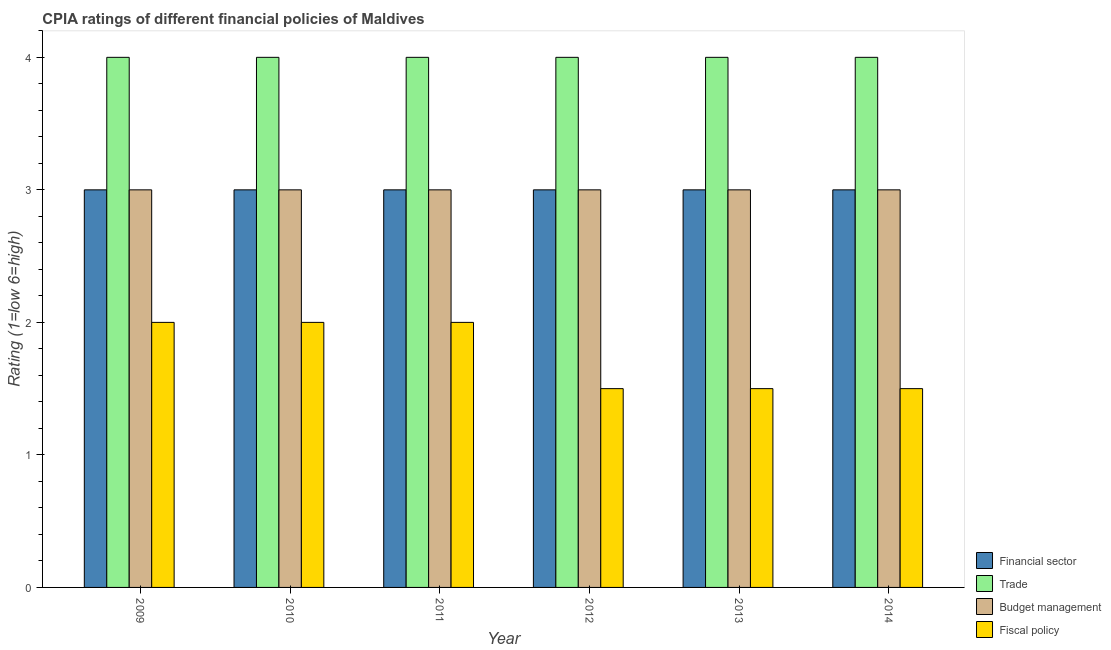How many groups of bars are there?
Make the answer very short. 6. Are the number of bars per tick equal to the number of legend labels?
Ensure brevity in your answer.  Yes. How many bars are there on the 2nd tick from the left?
Your answer should be compact. 4. What is the cpia rating of budget management in 2011?
Provide a short and direct response. 3. Across all years, what is the maximum cpia rating of trade?
Provide a short and direct response. 4. Across all years, what is the minimum cpia rating of budget management?
Ensure brevity in your answer.  3. In which year was the cpia rating of budget management maximum?
Offer a very short reply. 2009. In which year was the cpia rating of financial sector minimum?
Your answer should be very brief. 2009. What is the total cpia rating of trade in the graph?
Keep it short and to the point. 24. In how many years, is the cpia rating of trade greater than 1.8?
Your response must be concise. 6. Is the cpia rating of fiscal policy in 2013 less than that in 2014?
Ensure brevity in your answer.  No. Is the difference between the cpia rating of financial sector in 2011 and 2013 greater than the difference between the cpia rating of budget management in 2011 and 2013?
Your answer should be very brief. No. What is the difference between the highest and the second highest cpia rating of fiscal policy?
Your response must be concise. 0. Is the sum of the cpia rating of fiscal policy in 2012 and 2013 greater than the maximum cpia rating of financial sector across all years?
Your answer should be compact. Yes. What does the 4th bar from the left in 2011 represents?
Your answer should be very brief. Fiscal policy. What does the 4th bar from the right in 2010 represents?
Offer a very short reply. Financial sector. How many bars are there?
Make the answer very short. 24. Are all the bars in the graph horizontal?
Provide a succinct answer. No. How many years are there in the graph?
Make the answer very short. 6. What is the difference between two consecutive major ticks on the Y-axis?
Keep it short and to the point. 1. Does the graph contain any zero values?
Offer a very short reply. No. Does the graph contain grids?
Give a very brief answer. No. Where does the legend appear in the graph?
Your response must be concise. Bottom right. What is the title of the graph?
Ensure brevity in your answer.  CPIA ratings of different financial policies of Maldives. What is the label or title of the X-axis?
Keep it short and to the point. Year. What is the Rating (1=low 6=high) of Financial sector in 2009?
Your answer should be compact. 3. What is the Rating (1=low 6=high) in Budget management in 2009?
Offer a terse response. 3. What is the Rating (1=low 6=high) in Fiscal policy in 2010?
Keep it short and to the point. 2. What is the Rating (1=low 6=high) in Financial sector in 2011?
Provide a short and direct response. 3. What is the Rating (1=low 6=high) in Trade in 2011?
Your response must be concise. 4. What is the Rating (1=low 6=high) of Budget management in 2011?
Offer a very short reply. 3. What is the Rating (1=low 6=high) in Fiscal policy in 2012?
Offer a terse response. 1.5. What is the Rating (1=low 6=high) in Fiscal policy in 2013?
Your answer should be compact. 1.5. What is the Rating (1=low 6=high) in Budget management in 2014?
Ensure brevity in your answer.  3. Across all years, what is the maximum Rating (1=low 6=high) of Trade?
Offer a terse response. 4. Across all years, what is the maximum Rating (1=low 6=high) of Budget management?
Offer a very short reply. 3. Across all years, what is the maximum Rating (1=low 6=high) of Fiscal policy?
Your answer should be very brief. 2. Across all years, what is the minimum Rating (1=low 6=high) in Financial sector?
Your response must be concise. 3. Across all years, what is the minimum Rating (1=low 6=high) of Trade?
Provide a short and direct response. 4. What is the total Rating (1=low 6=high) in Trade in the graph?
Make the answer very short. 24. What is the total Rating (1=low 6=high) in Budget management in the graph?
Keep it short and to the point. 18. What is the total Rating (1=low 6=high) in Fiscal policy in the graph?
Keep it short and to the point. 10.5. What is the difference between the Rating (1=low 6=high) of Financial sector in 2009 and that in 2010?
Your answer should be compact. 0. What is the difference between the Rating (1=low 6=high) of Budget management in 2009 and that in 2011?
Offer a very short reply. 0. What is the difference between the Rating (1=low 6=high) in Fiscal policy in 2009 and that in 2011?
Ensure brevity in your answer.  0. What is the difference between the Rating (1=low 6=high) of Financial sector in 2009 and that in 2012?
Ensure brevity in your answer.  0. What is the difference between the Rating (1=low 6=high) in Financial sector in 2009 and that in 2013?
Offer a terse response. 0. What is the difference between the Rating (1=low 6=high) of Budget management in 2009 and that in 2013?
Provide a succinct answer. 0. What is the difference between the Rating (1=low 6=high) of Financial sector in 2009 and that in 2014?
Ensure brevity in your answer.  0. What is the difference between the Rating (1=low 6=high) in Fiscal policy in 2009 and that in 2014?
Ensure brevity in your answer.  0.5. What is the difference between the Rating (1=low 6=high) of Budget management in 2010 and that in 2011?
Offer a terse response. 0. What is the difference between the Rating (1=low 6=high) in Financial sector in 2010 and that in 2012?
Make the answer very short. 0. What is the difference between the Rating (1=low 6=high) of Trade in 2010 and that in 2012?
Give a very brief answer. 0. What is the difference between the Rating (1=low 6=high) of Fiscal policy in 2010 and that in 2012?
Provide a short and direct response. 0.5. What is the difference between the Rating (1=low 6=high) of Budget management in 2010 and that in 2013?
Your answer should be compact. 0. What is the difference between the Rating (1=low 6=high) of Fiscal policy in 2010 and that in 2013?
Ensure brevity in your answer.  0.5. What is the difference between the Rating (1=low 6=high) of Financial sector in 2010 and that in 2014?
Offer a terse response. 0. What is the difference between the Rating (1=low 6=high) of Trade in 2010 and that in 2014?
Keep it short and to the point. 0. What is the difference between the Rating (1=low 6=high) in Budget management in 2011 and that in 2012?
Offer a terse response. 0. What is the difference between the Rating (1=low 6=high) of Fiscal policy in 2011 and that in 2012?
Offer a very short reply. 0.5. What is the difference between the Rating (1=low 6=high) of Financial sector in 2011 and that in 2013?
Keep it short and to the point. 0. What is the difference between the Rating (1=low 6=high) of Fiscal policy in 2011 and that in 2013?
Provide a succinct answer. 0.5. What is the difference between the Rating (1=low 6=high) of Budget management in 2011 and that in 2014?
Your answer should be compact. 0. What is the difference between the Rating (1=low 6=high) of Fiscal policy in 2011 and that in 2014?
Provide a succinct answer. 0.5. What is the difference between the Rating (1=low 6=high) of Financial sector in 2012 and that in 2013?
Ensure brevity in your answer.  0. What is the difference between the Rating (1=low 6=high) in Financial sector in 2012 and that in 2014?
Offer a very short reply. 0. What is the difference between the Rating (1=low 6=high) in Trade in 2012 and that in 2014?
Give a very brief answer. 0. What is the difference between the Rating (1=low 6=high) in Budget management in 2012 and that in 2014?
Provide a short and direct response. 0. What is the difference between the Rating (1=low 6=high) of Fiscal policy in 2012 and that in 2014?
Your answer should be very brief. 0. What is the difference between the Rating (1=low 6=high) of Financial sector in 2013 and that in 2014?
Make the answer very short. 0. What is the difference between the Rating (1=low 6=high) of Budget management in 2013 and that in 2014?
Your response must be concise. 0. What is the difference between the Rating (1=low 6=high) in Financial sector in 2009 and the Rating (1=low 6=high) in Trade in 2010?
Your response must be concise. -1. What is the difference between the Rating (1=low 6=high) of Financial sector in 2009 and the Rating (1=low 6=high) of Budget management in 2010?
Provide a succinct answer. 0. What is the difference between the Rating (1=low 6=high) in Financial sector in 2009 and the Rating (1=low 6=high) in Fiscal policy in 2010?
Make the answer very short. 1. What is the difference between the Rating (1=low 6=high) in Trade in 2009 and the Rating (1=low 6=high) in Fiscal policy in 2010?
Provide a short and direct response. 2. What is the difference between the Rating (1=low 6=high) of Financial sector in 2009 and the Rating (1=low 6=high) of Trade in 2011?
Your answer should be very brief. -1. What is the difference between the Rating (1=low 6=high) of Financial sector in 2009 and the Rating (1=low 6=high) of Fiscal policy in 2011?
Provide a short and direct response. 1. What is the difference between the Rating (1=low 6=high) of Trade in 2009 and the Rating (1=low 6=high) of Budget management in 2011?
Ensure brevity in your answer.  1. What is the difference between the Rating (1=low 6=high) of Budget management in 2009 and the Rating (1=low 6=high) of Fiscal policy in 2011?
Keep it short and to the point. 1. What is the difference between the Rating (1=low 6=high) in Financial sector in 2009 and the Rating (1=low 6=high) in Trade in 2012?
Your answer should be compact. -1. What is the difference between the Rating (1=low 6=high) in Trade in 2009 and the Rating (1=low 6=high) in Fiscal policy in 2012?
Keep it short and to the point. 2.5. What is the difference between the Rating (1=low 6=high) in Financial sector in 2009 and the Rating (1=low 6=high) in Budget management in 2013?
Your response must be concise. 0. What is the difference between the Rating (1=low 6=high) in Trade in 2009 and the Rating (1=low 6=high) in Budget management in 2013?
Your answer should be very brief. 1. What is the difference between the Rating (1=low 6=high) of Budget management in 2009 and the Rating (1=low 6=high) of Fiscal policy in 2014?
Keep it short and to the point. 1.5. What is the difference between the Rating (1=low 6=high) in Financial sector in 2010 and the Rating (1=low 6=high) in Budget management in 2011?
Your answer should be compact. 0. What is the difference between the Rating (1=low 6=high) in Financial sector in 2010 and the Rating (1=low 6=high) in Trade in 2012?
Your response must be concise. -1. What is the difference between the Rating (1=low 6=high) in Financial sector in 2010 and the Rating (1=low 6=high) in Budget management in 2012?
Offer a terse response. 0. What is the difference between the Rating (1=low 6=high) of Financial sector in 2010 and the Rating (1=low 6=high) of Fiscal policy in 2012?
Your answer should be very brief. 1.5. What is the difference between the Rating (1=low 6=high) of Budget management in 2010 and the Rating (1=low 6=high) of Fiscal policy in 2012?
Provide a succinct answer. 1.5. What is the difference between the Rating (1=low 6=high) of Financial sector in 2010 and the Rating (1=low 6=high) of Trade in 2013?
Offer a very short reply. -1. What is the difference between the Rating (1=low 6=high) of Financial sector in 2010 and the Rating (1=low 6=high) of Budget management in 2013?
Give a very brief answer. 0. What is the difference between the Rating (1=low 6=high) in Financial sector in 2010 and the Rating (1=low 6=high) in Fiscal policy in 2013?
Keep it short and to the point. 1.5. What is the difference between the Rating (1=low 6=high) in Trade in 2010 and the Rating (1=low 6=high) in Fiscal policy in 2013?
Offer a very short reply. 2.5. What is the difference between the Rating (1=low 6=high) in Budget management in 2010 and the Rating (1=low 6=high) in Fiscal policy in 2013?
Your response must be concise. 1.5. What is the difference between the Rating (1=low 6=high) in Financial sector in 2010 and the Rating (1=low 6=high) in Trade in 2014?
Make the answer very short. -1. What is the difference between the Rating (1=low 6=high) of Financial sector in 2010 and the Rating (1=low 6=high) of Budget management in 2014?
Your answer should be compact. 0. What is the difference between the Rating (1=low 6=high) in Trade in 2010 and the Rating (1=low 6=high) in Fiscal policy in 2014?
Your answer should be very brief. 2.5. What is the difference between the Rating (1=low 6=high) of Budget management in 2010 and the Rating (1=low 6=high) of Fiscal policy in 2014?
Provide a short and direct response. 1.5. What is the difference between the Rating (1=low 6=high) of Financial sector in 2011 and the Rating (1=low 6=high) of Trade in 2012?
Provide a short and direct response. -1. What is the difference between the Rating (1=low 6=high) in Trade in 2011 and the Rating (1=low 6=high) in Budget management in 2012?
Offer a terse response. 1. What is the difference between the Rating (1=low 6=high) in Budget management in 2011 and the Rating (1=low 6=high) in Fiscal policy in 2012?
Provide a succinct answer. 1.5. What is the difference between the Rating (1=low 6=high) in Financial sector in 2011 and the Rating (1=low 6=high) in Trade in 2013?
Provide a succinct answer. -1. What is the difference between the Rating (1=low 6=high) in Financial sector in 2011 and the Rating (1=low 6=high) in Budget management in 2013?
Provide a succinct answer. 0. What is the difference between the Rating (1=low 6=high) in Financial sector in 2011 and the Rating (1=low 6=high) in Fiscal policy in 2013?
Provide a succinct answer. 1.5. What is the difference between the Rating (1=low 6=high) of Trade in 2011 and the Rating (1=low 6=high) of Budget management in 2013?
Offer a very short reply. 1. What is the difference between the Rating (1=low 6=high) in Financial sector in 2011 and the Rating (1=low 6=high) in Trade in 2014?
Make the answer very short. -1. What is the difference between the Rating (1=low 6=high) in Trade in 2011 and the Rating (1=low 6=high) in Budget management in 2014?
Ensure brevity in your answer.  1. What is the difference between the Rating (1=low 6=high) of Financial sector in 2012 and the Rating (1=low 6=high) of Fiscal policy in 2013?
Your answer should be very brief. 1.5. What is the difference between the Rating (1=low 6=high) of Budget management in 2012 and the Rating (1=low 6=high) of Fiscal policy in 2013?
Give a very brief answer. 1.5. What is the difference between the Rating (1=low 6=high) of Financial sector in 2012 and the Rating (1=low 6=high) of Budget management in 2014?
Provide a succinct answer. 0. What is the difference between the Rating (1=low 6=high) of Trade in 2012 and the Rating (1=low 6=high) of Budget management in 2014?
Keep it short and to the point. 1. What is the difference between the Rating (1=low 6=high) of Trade in 2012 and the Rating (1=low 6=high) of Fiscal policy in 2014?
Ensure brevity in your answer.  2.5. What is the difference between the Rating (1=low 6=high) of Financial sector in 2013 and the Rating (1=low 6=high) of Budget management in 2014?
Keep it short and to the point. 0. What is the difference between the Rating (1=low 6=high) in Financial sector in 2013 and the Rating (1=low 6=high) in Fiscal policy in 2014?
Your answer should be compact. 1.5. What is the average Rating (1=low 6=high) of Trade per year?
Give a very brief answer. 4. In the year 2009, what is the difference between the Rating (1=low 6=high) in Financial sector and Rating (1=low 6=high) in Trade?
Your answer should be very brief. -1. In the year 2009, what is the difference between the Rating (1=low 6=high) in Budget management and Rating (1=low 6=high) in Fiscal policy?
Provide a succinct answer. 1. In the year 2010, what is the difference between the Rating (1=low 6=high) of Financial sector and Rating (1=low 6=high) of Trade?
Provide a short and direct response. -1. In the year 2010, what is the difference between the Rating (1=low 6=high) in Financial sector and Rating (1=low 6=high) in Budget management?
Your answer should be very brief. 0. In the year 2010, what is the difference between the Rating (1=low 6=high) in Trade and Rating (1=low 6=high) in Fiscal policy?
Provide a succinct answer. 2. In the year 2011, what is the difference between the Rating (1=low 6=high) of Financial sector and Rating (1=low 6=high) of Trade?
Offer a very short reply. -1. In the year 2011, what is the difference between the Rating (1=low 6=high) in Trade and Rating (1=low 6=high) in Budget management?
Provide a succinct answer. 1. In the year 2011, what is the difference between the Rating (1=low 6=high) in Trade and Rating (1=low 6=high) in Fiscal policy?
Offer a terse response. 2. In the year 2012, what is the difference between the Rating (1=low 6=high) of Financial sector and Rating (1=low 6=high) of Trade?
Keep it short and to the point. -1. In the year 2012, what is the difference between the Rating (1=low 6=high) of Financial sector and Rating (1=low 6=high) of Budget management?
Your answer should be very brief. 0. In the year 2012, what is the difference between the Rating (1=low 6=high) of Financial sector and Rating (1=low 6=high) of Fiscal policy?
Offer a very short reply. 1.5. In the year 2012, what is the difference between the Rating (1=low 6=high) of Trade and Rating (1=low 6=high) of Budget management?
Offer a terse response. 1. In the year 2012, what is the difference between the Rating (1=low 6=high) in Trade and Rating (1=low 6=high) in Fiscal policy?
Your answer should be very brief. 2.5. In the year 2012, what is the difference between the Rating (1=low 6=high) in Budget management and Rating (1=low 6=high) in Fiscal policy?
Ensure brevity in your answer.  1.5. In the year 2013, what is the difference between the Rating (1=low 6=high) of Financial sector and Rating (1=low 6=high) of Budget management?
Keep it short and to the point. 0. In the year 2013, what is the difference between the Rating (1=low 6=high) in Financial sector and Rating (1=low 6=high) in Fiscal policy?
Your answer should be very brief. 1.5. In the year 2014, what is the difference between the Rating (1=low 6=high) in Trade and Rating (1=low 6=high) in Budget management?
Ensure brevity in your answer.  1. In the year 2014, what is the difference between the Rating (1=low 6=high) of Trade and Rating (1=low 6=high) of Fiscal policy?
Offer a terse response. 2.5. What is the ratio of the Rating (1=low 6=high) in Trade in 2009 to that in 2010?
Keep it short and to the point. 1. What is the ratio of the Rating (1=low 6=high) of Budget management in 2009 to that in 2011?
Your answer should be very brief. 1. What is the ratio of the Rating (1=low 6=high) of Fiscal policy in 2009 to that in 2011?
Your answer should be very brief. 1. What is the ratio of the Rating (1=low 6=high) in Fiscal policy in 2009 to that in 2012?
Keep it short and to the point. 1.33. What is the ratio of the Rating (1=low 6=high) in Financial sector in 2009 to that in 2013?
Keep it short and to the point. 1. What is the ratio of the Rating (1=low 6=high) of Fiscal policy in 2009 to that in 2013?
Your answer should be very brief. 1.33. What is the ratio of the Rating (1=low 6=high) of Financial sector in 2009 to that in 2014?
Make the answer very short. 1. What is the ratio of the Rating (1=low 6=high) of Trade in 2009 to that in 2014?
Keep it short and to the point. 1. What is the ratio of the Rating (1=low 6=high) in Budget management in 2010 to that in 2011?
Make the answer very short. 1. What is the ratio of the Rating (1=low 6=high) of Financial sector in 2010 to that in 2012?
Your answer should be very brief. 1. What is the ratio of the Rating (1=low 6=high) of Trade in 2010 to that in 2012?
Provide a succinct answer. 1. What is the ratio of the Rating (1=low 6=high) in Budget management in 2010 to that in 2012?
Provide a succinct answer. 1. What is the ratio of the Rating (1=low 6=high) in Trade in 2010 to that in 2013?
Give a very brief answer. 1. What is the ratio of the Rating (1=low 6=high) of Budget management in 2010 to that in 2013?
Keep it short and to the point. 1. What is the ratio of the Rating (1=low 6=high) in Fiscal policy in 2010 to that in 2013?
Make the answer very short. 1.33. What is the ratio of the Rating (1=low 6=high) of Budget management in 2010 to that in 2014?
Your answer should be very brief. 1. What is the ratio of the Rating (1=low 6=high) in Trade in 2011 to that in 2012?
Your answer should be very brief. 1. What is the ratio of the Rating (1=low 6=high) in Budget management in 2011 to that in 2012?
Offer a very short reply. 1. What is the ratio of the Rating (1=low 6=high) of Financial sector in 2011 to that in 2013?
Offer a terse response. 1. What is the ratio of the Rating (1=low 6=high) in Trade in 2011 to that in 2013?
Keep it short and to the point. 1. What is the ratio of the Rating (1=low 6=high) of Budget management in 2011 to that in 2014?
Your answer should be very brief. 1. What is the ratio of the Rating (1=low 6=high) in Fiscal policy in 2011 to that in 2014?
Offer a very short reply. 1.33. What is the ratio of the Rating (1=low 6=high) in Fiscal policy in 2012 to that in 2013?
Your answer should be very brief. 1. What is the ratio of the Rating (1=low 6=high) of Financial sector in 2012 to that in 2014?
Offer a terse response. 1. What is the ratio of the Rating (1=low 6=high) in Trade in 2012 to that in 2014?
Keep it short and to the point. 1. What is the ratio of the Rating (1=low 6=high) in Budget management in 2012 to that in 2014?
Your answer should be very brief. 1. What is the ratio of the Rating (1=low 6=high) of Financial sector in 2013 to that in 2014?
Your answer should be very brief. 1. What is the ratio of the Rating (1=low 6=high) in Trade in 2013 to that in 2014?
Provide a succinct answer. 1. What is the ratio of the Rating (1=low 6=high) in Budget management in 2013 to that in 2014?
Ensure brevity in your answer.  1. What is the difference between the highest and the second highest Rating (1=low 6=high) of Financial sector?
Provide a short and direct response. 0. What is the difference between the highest and the second highest Rating (1=low 6=high) of Trade?
Ensure brevity in your answer.  0. What is the difference between the highest and the second highest Rating (1=low 6=high) in Fiscal policy?
Your answer should be very brief. 0. What is the difference between the highest and the lowest Rating (1=low 6=high) of Financial sector?
Provide a short and direct response. 0. What is the difference between the highest and the lowest Rating (1=low 6=high) of Budget management?
Make the answer very short. 0. 